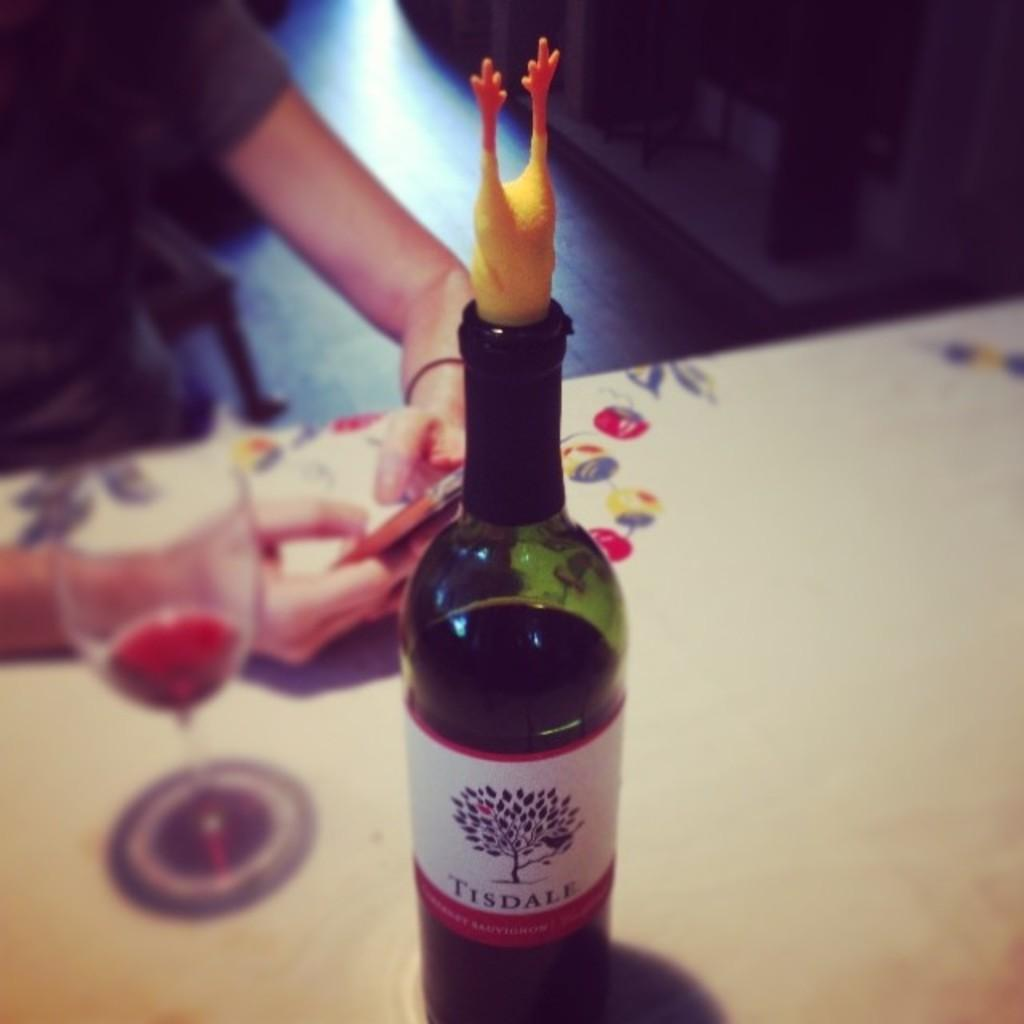Provide a one-sentence caption for the provided image. A bottle of Tisdale Cabernet Sauvignon is on a table near a person with a cell phone. 